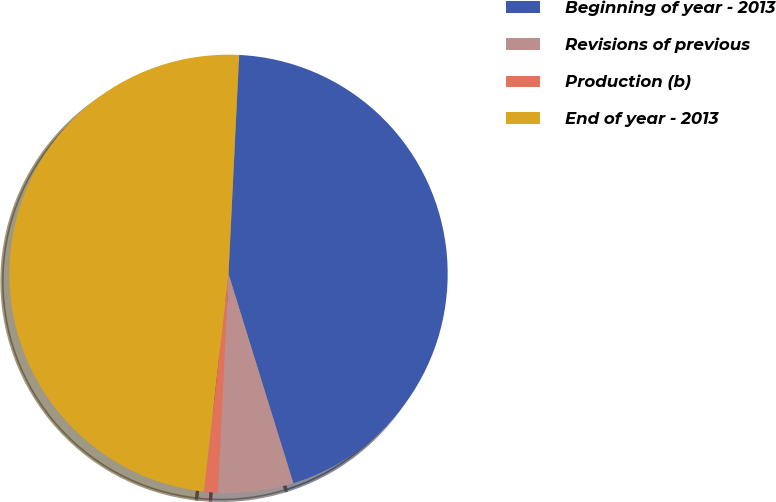Convert chart. <chart><loc_0><loc_0><loc_500><loc_500><pie_chart><fcel>Beginning of year - 2013<fcel>Revisions of previous<fcel>Production (b)<fcel>End of year - 2013<nl><fcel>44.45%<fcel>5.55%<fcel>1.02%<fcel>48.98%<nl></chart> 